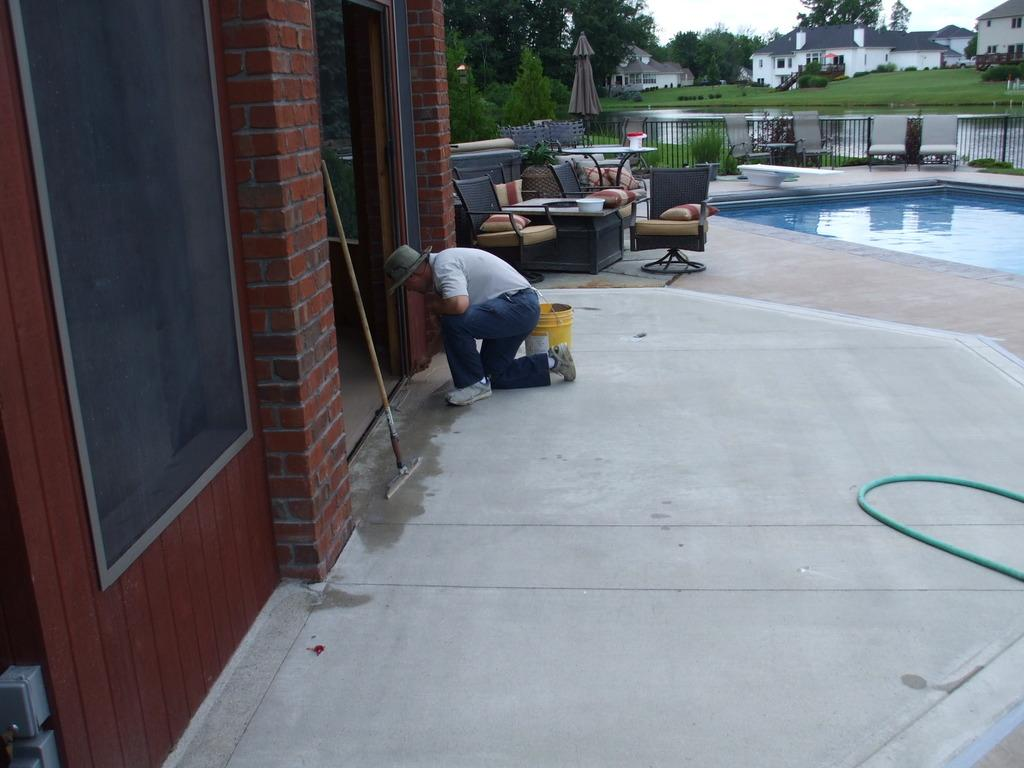What is the main subject of the image? There is a man in the image. What is the man doing in the image? The man is cleaning the entrance door. What type of yak can be seen sitting on the sofa in the image? There is no yak or sofa present in the image; it only features a man cleaning the entrance door. 